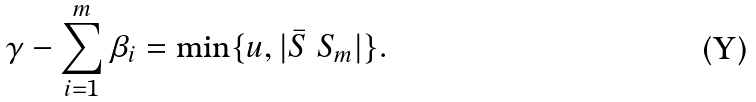Convert formula to latex. <formula><loc_0><loc_0><loc_500><loc_500>\gamma - \sum _ { i = 1 } ^ { m } \beta _ { i } = \min \{ u , | \bar { S } \ S _ { m } | \} .</formula> 